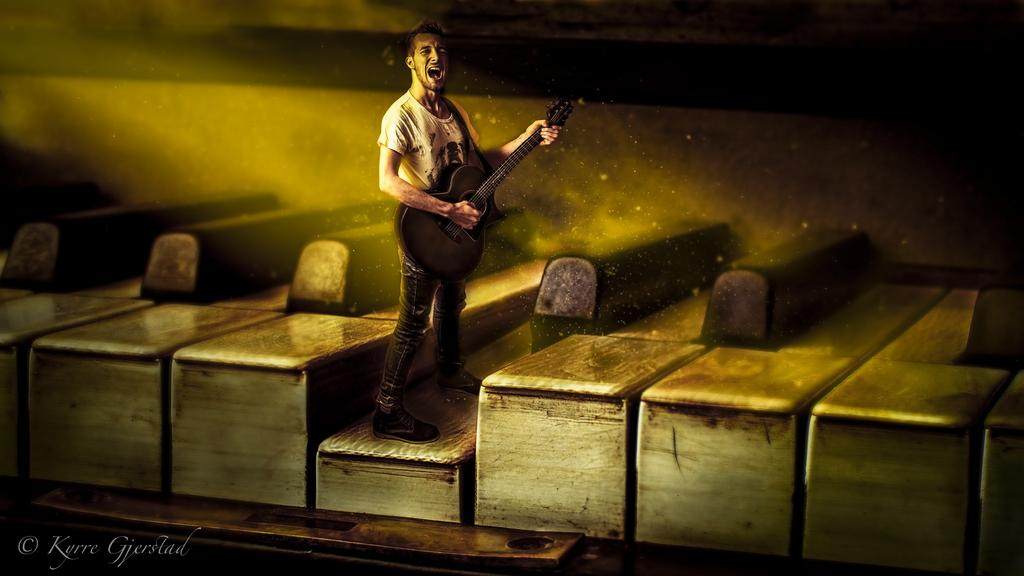What is the main subject of the image? There is a man standing in the middle of the image. What is the man holding in the image? The man is holding a music instrument. Can you describe the music instrument? The music instrument is black in color. What other objects can be seen in the image? There are wooden blocks in the image. How are the wooden blocks characterized? The wooden blocks are white in color and are on the right side of the image. What rule does the man follow while playing the music instrument in the image? There is no indication of any rules being followed in the image, as it only shows a man holding a music instrument and wooden blocks. What plot is being developed in the image? The image does not depict a plot or story; it is a static scene with a man holding a music instrument and wooden blocks. 